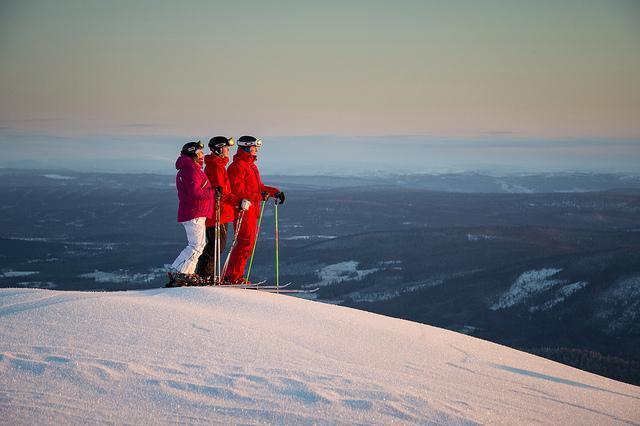How many people are there?
Give a very brief answer. 3. How many toothbrushes are there?
Give a very brief answer. 0. 